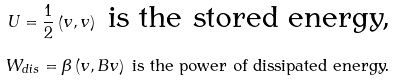<formula> <loc_0><loc_0><loc_500><loc_500>U = \frac { 1 } { 2 } \left ( v , v \right ) \text { is the stored energy,} \\ W _ { d i s } = \beta \left ( v , B v \right ) \text { is the power of dissipated energy.}</formula> 